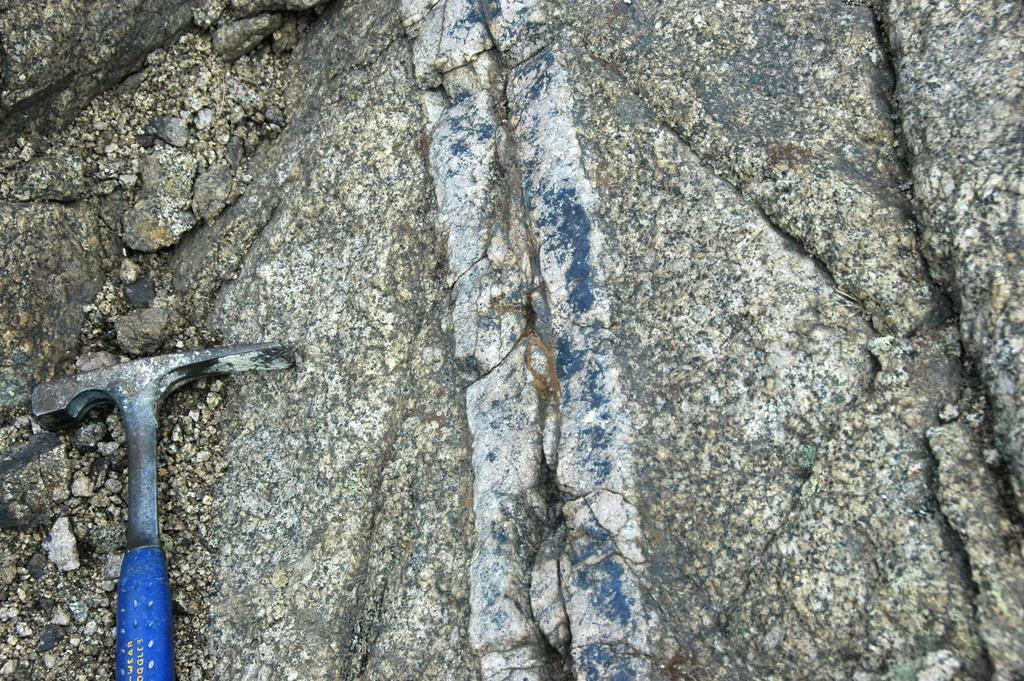What object can be seen in the image? There is a hammer in the image. What is the hammer resting on in the image? The hammer is on a rock surface. What type of scene is depicted in the image involving a giraffe? There is no giraffe present in the image; it only features a hammer on a rock surface. 